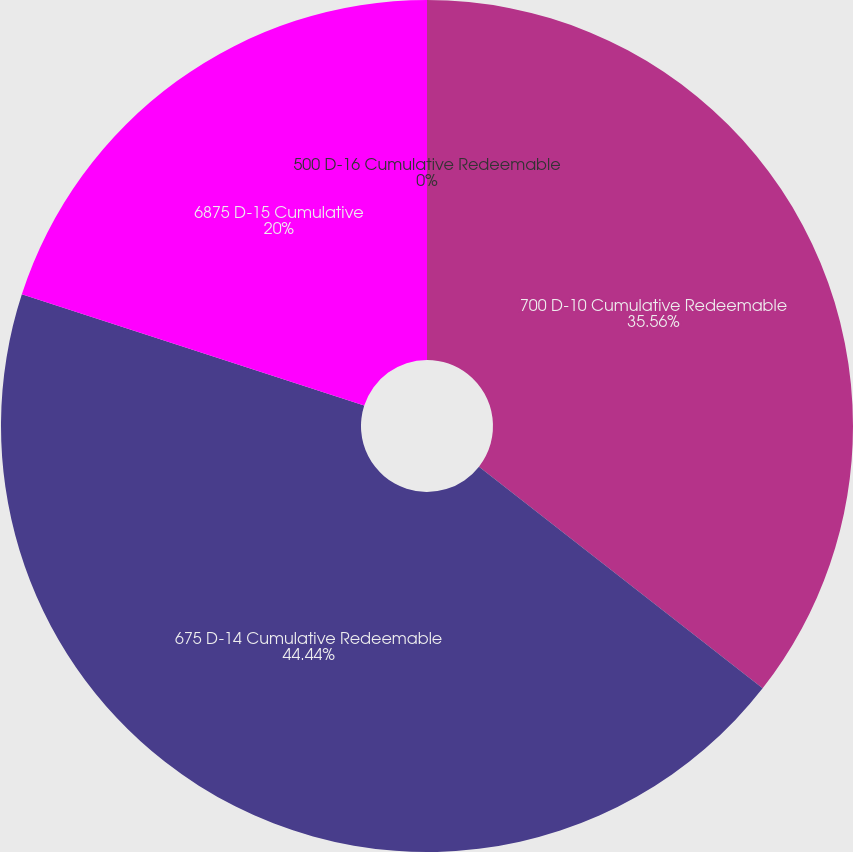<chart> <loc_0><loc_0><loc_500><loc_500><pie_chart><fcel>700 D-10 Cumulative Redeemable<fcel>675 D-14 Cumulative Redeemable<fcel>6875 D-15 Cumulative<fcel>500 D-16 Cumulative Redeemable<nl><fcel>35.56%<fcel>44.44%<fcel>20.0%<fcel>0.0%<nl></chart> 